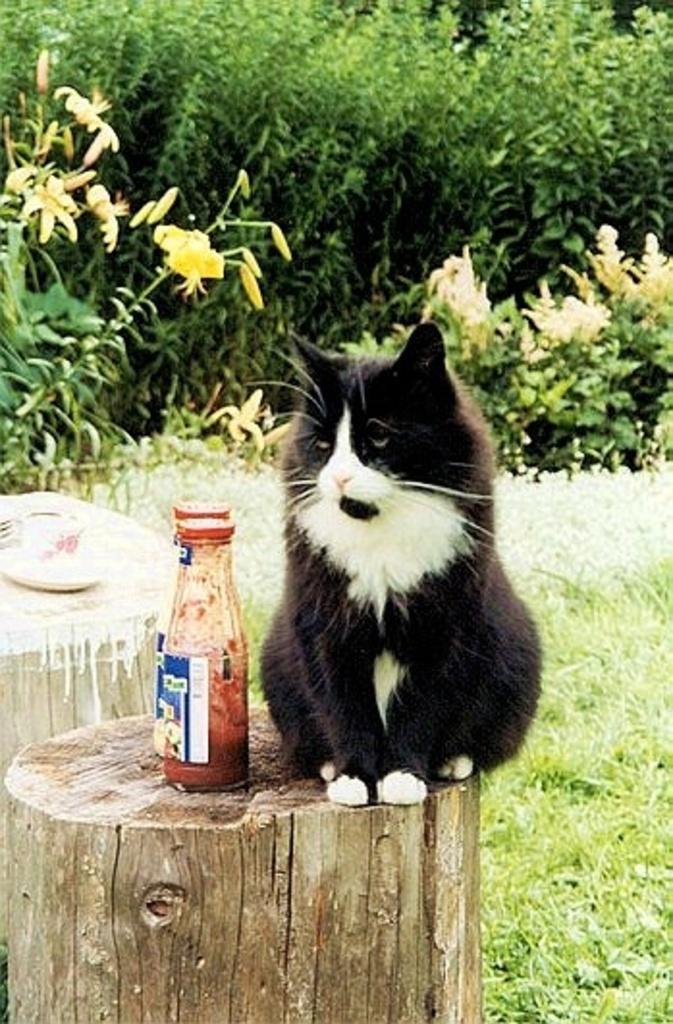Could you give a brief overview of what you see in this image? In this image, There is a wooden block and a cat sitting on the wooden block and in the background there is grass and some plants in green color. 